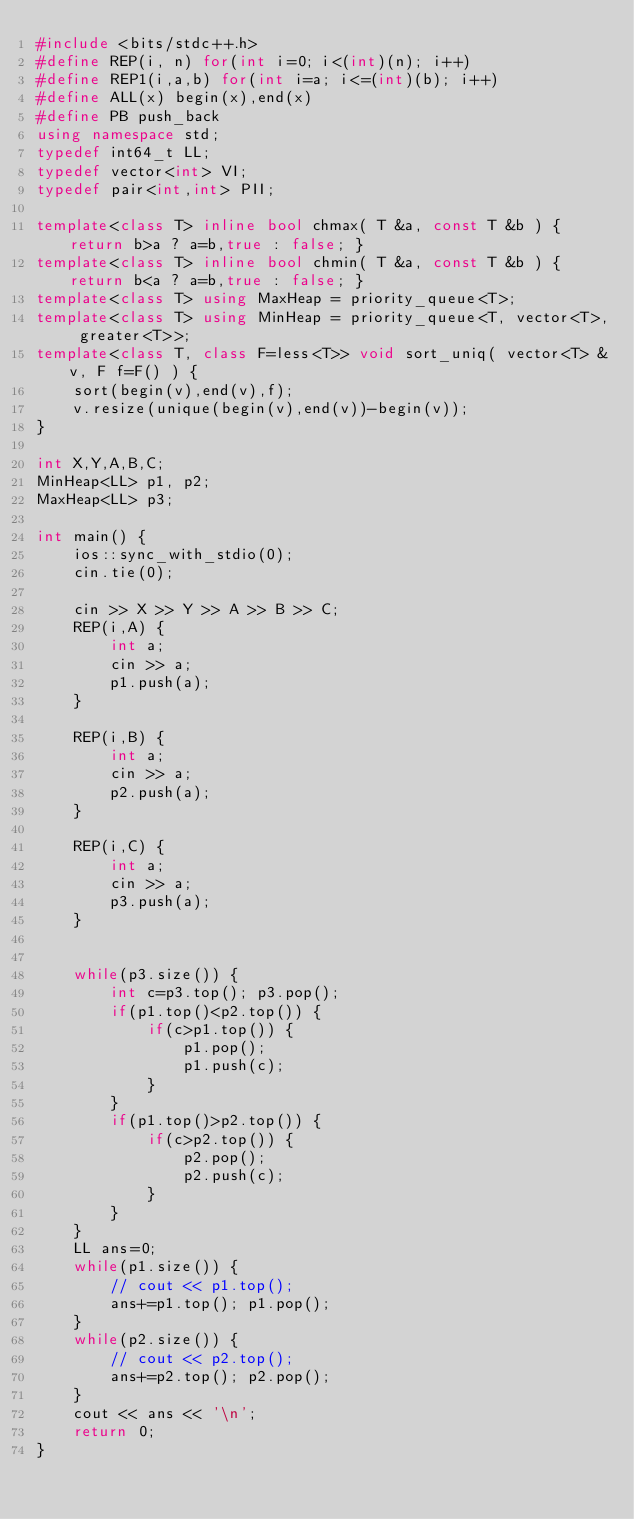Convert code to text. <code><loc_0><loc_0><loc_500><loc_500><_C++_>#include <bits/stdc++.h>
#define REP(i, n) for(int i=0; i<(int)(n); i++)
#define REP1(i,a,b) for(int i=a; i<=(int)(b); i++)
#define ALL(x) begin(x),end(x)
#define PB push_back
using namespace std;
typedef int64_t LL;
typedef vector<int> VI;
typedef pair<int,int> PII;

template<class T> inline bool chmax( T &a, const T &b ) { return b>a ? a=b,true : false; }
template<class T> inline bool chmin( T &a, const T &b ) { return b<a ? a=b,true : false; }
template<class T> using MaxHeap = priority_queue<T>;
template<class T> using MinHeap = priority_queue<T, vector<T>, greater<T>>;
template<class T, class F=less<T>> void sort_uniq( vector<T> &v, F f=F() ) {
    sort(begin(v),end(v),f);
    v.resize(unique(begin(v),end(v))-begin(v));
}

int X,Y,A,B,C;
MinHeap<LL> p1, p2;
MaxHeap<LL> p3;

int main() {
    ios::sync_with_stdio(0);
    cin.tie(0);
    
    cin >> X >> Y >> A >> B >> C;
    REP(i,A) {
        int a;
        cin >> a;
        p1.push(a);
    }

    REP(i,B) {
        int a;
        cin >> a;
        p2.push(a);
    }

    REP(i,C) {
        int a;
        cin >> a;
        p3.push(a);
    }


    while(p3.size()) {
        int c=p3.top(); p3.pop();
        if(p1.top()<p2.top()) {
            if(c>p1.top()) {
                p1.pop();
                p1.push(c);
            }
        }
        if(p1.top()>p2.top()) {
            if(c>p2.top()) {
                p2.pop();
                p2.push(c);
            }
        }
    }
    LL ans=0;
    while(p1.size()) {
        // cout << p1.top();
        ans+=p1.top(); p1.pop();
    }
    while(p2.size()) {
        // cout << p2.top();
        ans+=p2.top(); p2.pop();
    }
    cout << ans << '\n';
    return 0;
}</code> 